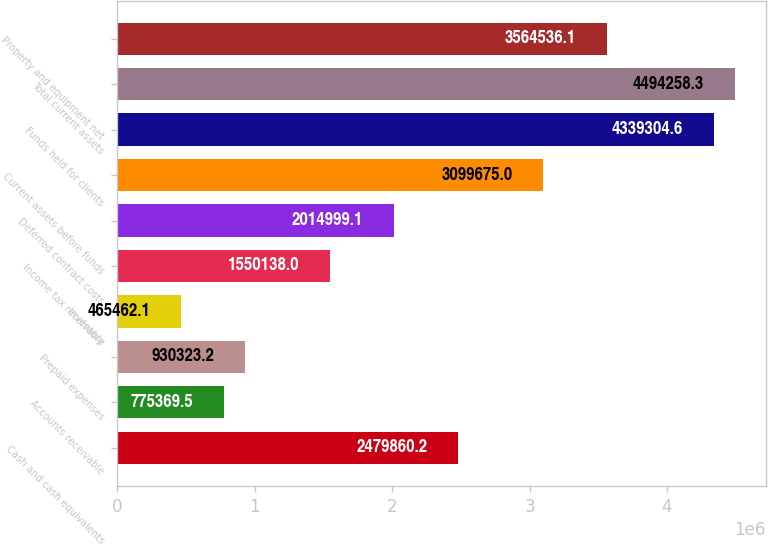<chart> <loc_0><loc_0><loc_500><loc_500><bar_chart><fcel>Cash and cash equivalents<fcel>Accounts receivable<fcel>Prepaid expenses<fcel>Inventory<fcel>Income tax receivable<fcel>Deferred contract costs<fcel>Current assets before funds<fcel>Funds held for clients<fcel>Total current assets<fcel>Property and equipment net<nl><fcel>2.47986e+06<fcel>775370<fcel>930323<fcel>465462<fcel>1.55014e+06<fcel>2.015e+06<fcel>3.09968e+06<fcel>4.3393e+06<fcel>4.49426e+06<fcel>3.56454e+06<nl></chart> 